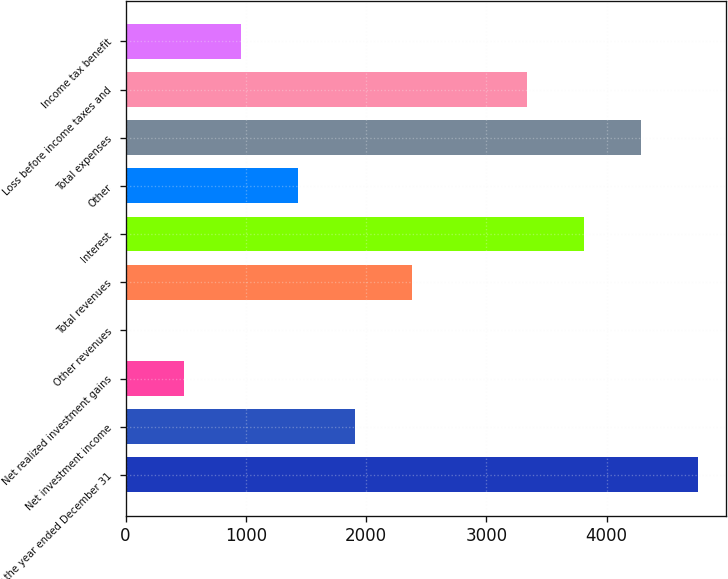<chart> <loc_0><loc_0><loc_500><loc_500><bar_chart><fcel>For the year ended December 31<fcel>Net investment income<fcel>Net realized investment gains<fcel>Other revenues<fcel>Total revenues<fcel>Interest<fcel>Other<fcel>Total expenses<fcel>Loss before income taxes and<fcel>Income tax benefit<nl><fcel>4757<fcel>1910<fcel>486.5<fcel>12<fcel>2384.5<fcel>3808<fcel>1435.5<fcel>4282.5<fcel>3333.5<fcel>961<nl></chart> 